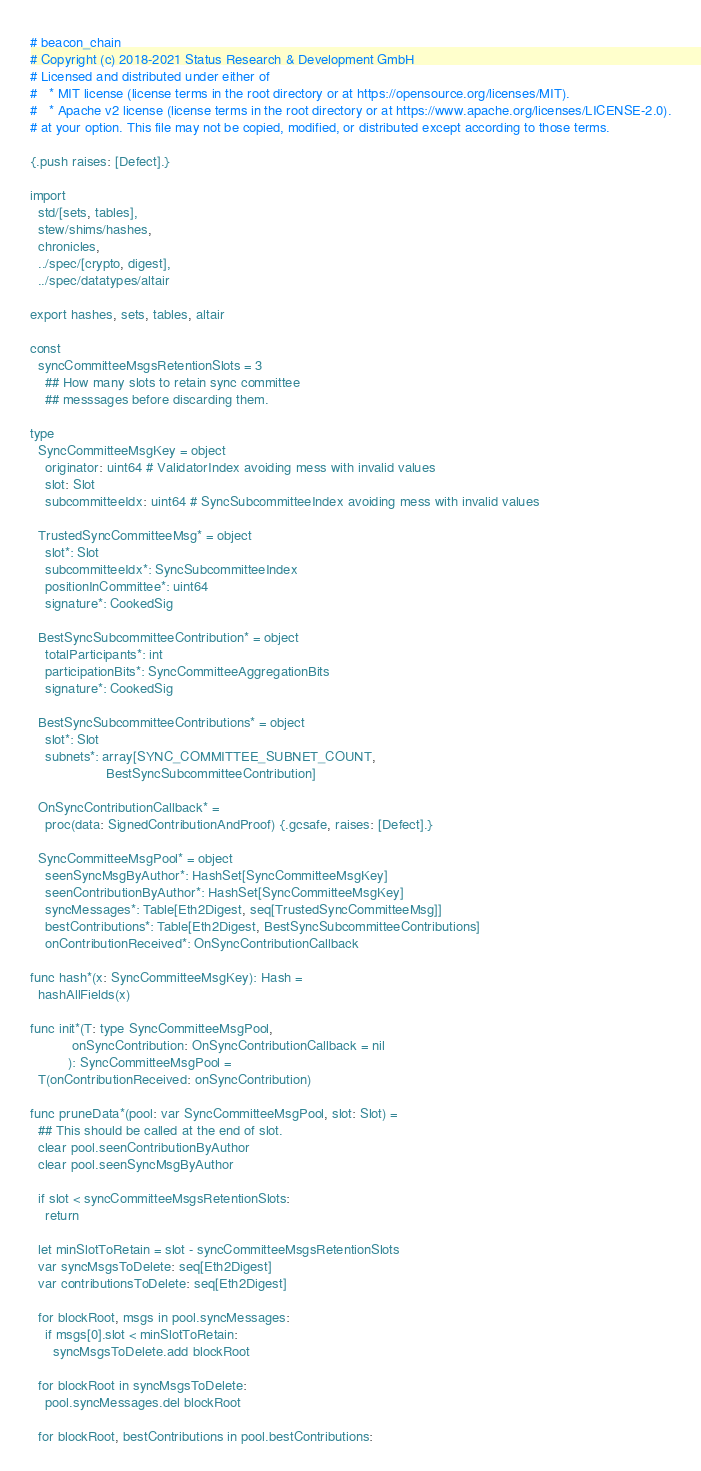<code> <loc_0><loc_0><loc_500><loc_500><_Nim_># beacon_chain
# Copyright (c) 2018-2021 Status Research & Development GmbH
# Licensed and distributed under either of
#   * MIT license (license terms in the root directory or at https://opensource.org/licenses/MIT).
#   * Apache v2 license (license terms in the root directory or at https://www.apache.org/licenses/LICENSE-2.0).
# at your option. This file may not be copied, modified, or distributed except according to those terms.

{.push raises: [Defect].}

import
  std/[sets, tables],
  stew/shims/hashes,
  chronicles,
  ../spec/[crypto, digest],
  ../spec/datatypes/altair

export hashes, sets, tables, altair

const
  syncCommitteeMsgsRetentionSlots = 3
    ## How many slots to retain sync committee
    ## messsages before discarding them.

type
  SyncCommitteeMsgKey = object
    originator: uint64 # ValidatorIndex avoiding mess with invalid values
    slot: Slot
    subcommitteeIdx: uint64 # SyncSubcommitteeIndex avoiding mess with invalid values

  TrustedSyncCommitteeMsg* = object
    slot*: Slot
    subcommitteeIdx*: SyncSubcommitteeIndex
    positionInCommittee*: uint64
    signature*: CookedSig

  BestSyncSubcommitteeContribution* = object
    totalParticipants*: int
    participationBits*: SyncCommitteeAggregationBits
    signature*: CookedSig

  BestSyncSubcommitteeContributions* = object
    slot*: Slot
    subnets*: array[SYNC_COMMITTEE_SUBNET_COUNT,
                    BestSyncSubcommitteeContribution]

  OnSyncContributionCallback* =
    proc(data: SignedContributionAndProof) {.gcsafe, raises: [Defect].}

  SyncCommitteeMsgPool* = object
    seenSyncMsgByAuthor*: HashSet[SyncCommitteeMsgKey]
    seenContributionByAuthor*: HashSet[SyncCommitteeMsgKey]
    syncMessages*: Table[Eth2Digest, seq[TrustedSyncCommitteeMsg]]
    bestContributions*: Table[Eth2Digest, BestSyncSubcommitteeContributions]
    onContributionReceived*: OnSyncContributionCallback

func hash*(x: SyncCommitteeMsgKey): Hash =
  hashAllFields(x)

func init*(T: type SyncCommitteeMsgPool,
           onSyncContribution: OnSyncContributionCallback = nil
          ): SyncCommitteeMsgPool =
  T(onContributionReceived: onSyncContribution)

func pruneData*(pool: var SyncCommitteeMsgPool, slot: Slot) =
  ## This should be called at the end of slot.
  clear pool.seenContributionByAuthor
  clear pool.seenSyncMsgByAuthor

  if slot < syncCommitteeMsgsRetentionSlots:
    return

  let minSlotToRetain = slot - syncCommitteeMsgsRetentionSlots
  var syncMsgsToDelete: seq[Eth2Digest]
  var contributionsToDelete: seq[Eth2Digest]

  for blockRoot, msgs in pool.syncMessages:
    if msgs[0].slot < minSlotToRetain:
      syncMsgsToDelete.add blockRoot

  for blockRoot in syncMsgsToDelete:
    pool.syncMessages.del blockRoot

  for blockRoot, bestContributions in pool.bestContributions:</code> 